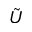Convert formula to latex. <formula><loc_0><loc_0><loc_500><loc_500>\tilde { U }</formula> 